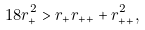Convert formula to latex. <formula><loc_0><loc_0><loc_500><loc_500>1 8 r _ { + } ^ { 2 } > r _ { + } r _ { + + } + r _ { + + } ^ { 2 } ,</formula> 